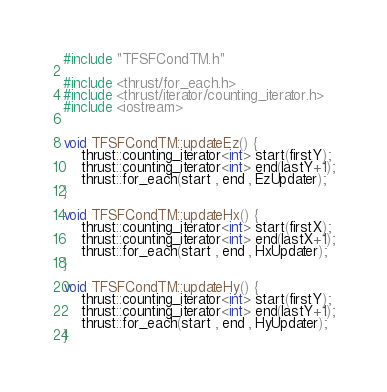<code> <loc_0><loc_0><loc_500><loc_500><_Cuda_>#include "TFSFCondTM.h"

#include <thrust/for_each.h>
#include <thrust/iterator/counting_iterator.h>
#include <iostream>


void TFSFCondTM::updateEz() {
	thrust::counting_iterator<int> start(firstY);
	thrust::counting_iterator<int> end(lastY+1);
	thrust::for_each(start , end , EzUpdater);
}

void TFSFCondTM::updateHx() {
	thrust::counting_iterator<int> start(firstX);
	thrust::counting_iterator<int> end(lastX+1);
	thrust::for_each(start , end , HxUpdater);
}

void TFSFCondTM::updateHy() {
	thrust::counting_iterator<int> start(firstY);
	thrust::counting_iterator<int> end(lastY+1);
	thrust::for_each(start , end , HyUpdater);
}
</code> 